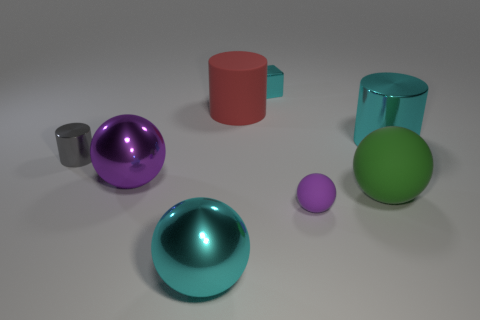Add 1 big green cubes. How many objects exist? 9 Subtract all yellow cylinders. Subtract all yellow blocks. How many cylinders are left? 3 Subtract all blocks. How many objects are left? 7 Subtract all tiny cyan cubes. Subtract all gray shiny cylinders. How many objects are left? 6 Add 1 small matte things. How many small matte things are left? 2 Add 6 tiny green metallic blocks. How many tiny green metallic blocks exist? 6 Subtract 0 yellow cylinders. How many objects are left? 8 